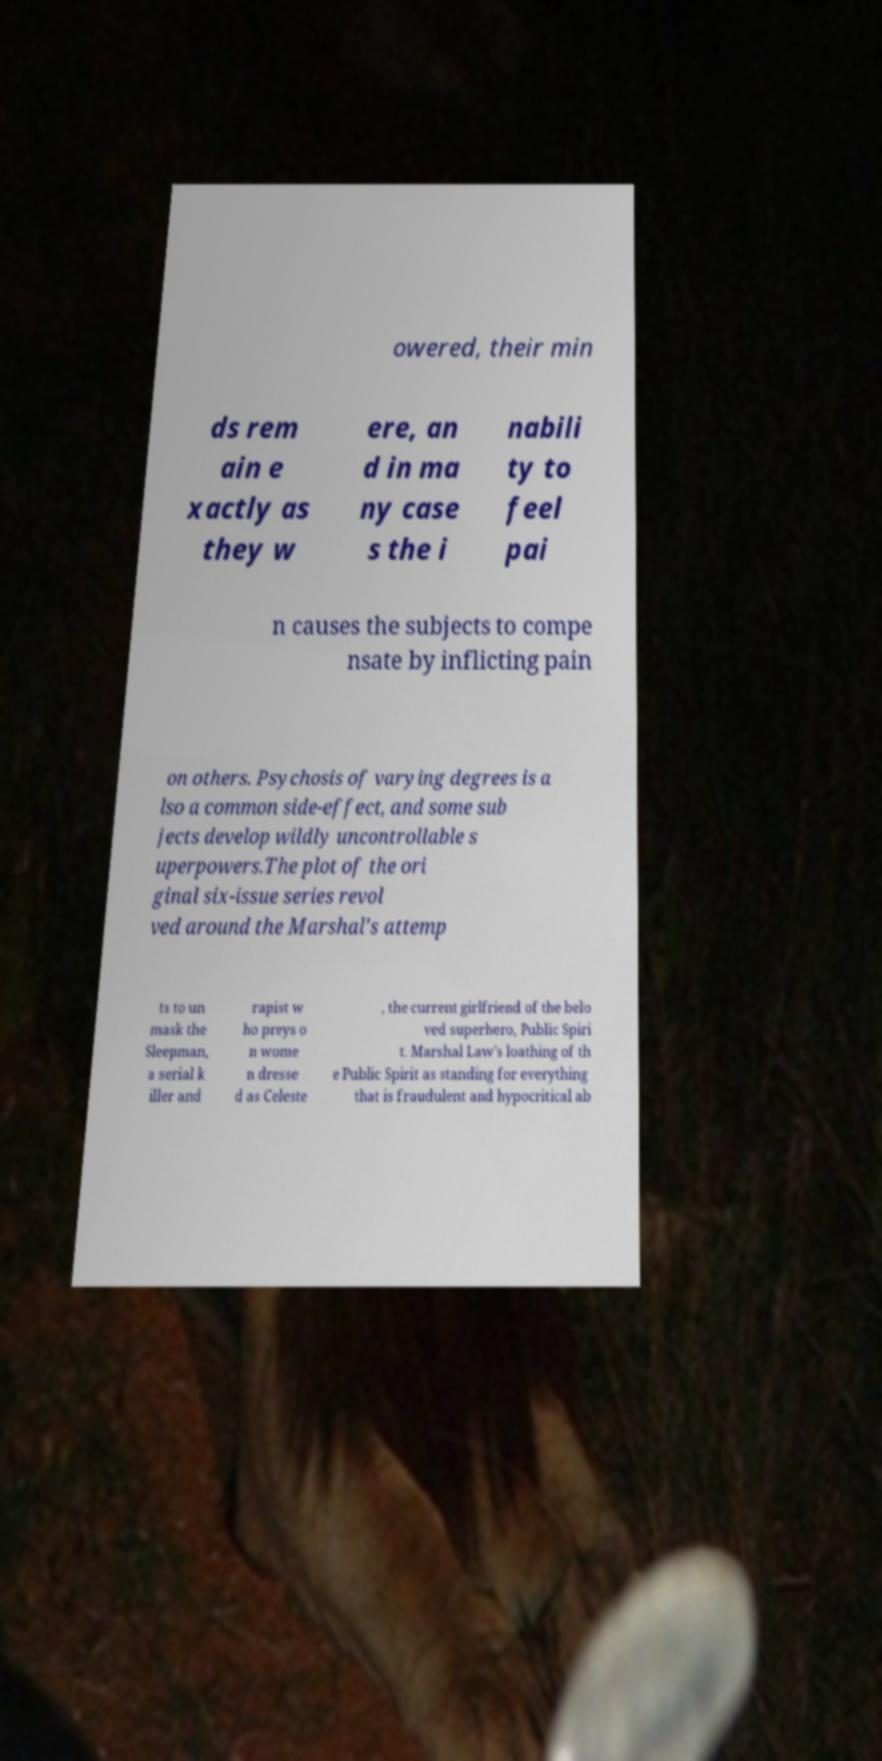Could you assist in decoding the text presented in this image and type it out clearly? owered, their min ds rem ain e xactly as they w ere, an d in ma ny case s the i nabili ty to feel pai n causes the subjects to compe nsate by inflicting pain on others. Psychosis of varying degrees is a lso a common side-effect, and some sub jects develop wildly uncontrollable s uperpowers.The plot of the ori ginal six-issue series revol ved around the Marshal's attemp ts to un mask the Sleepman, a serial k iller and rapist w ho preys o n wome n dresse d as Celeste , the current girlfriend of the belo ved superhero, Public Spiri t. Marshal Law's loathing of th e Public Spirit as standing for everything that is fraudulent and hypocritical ab 